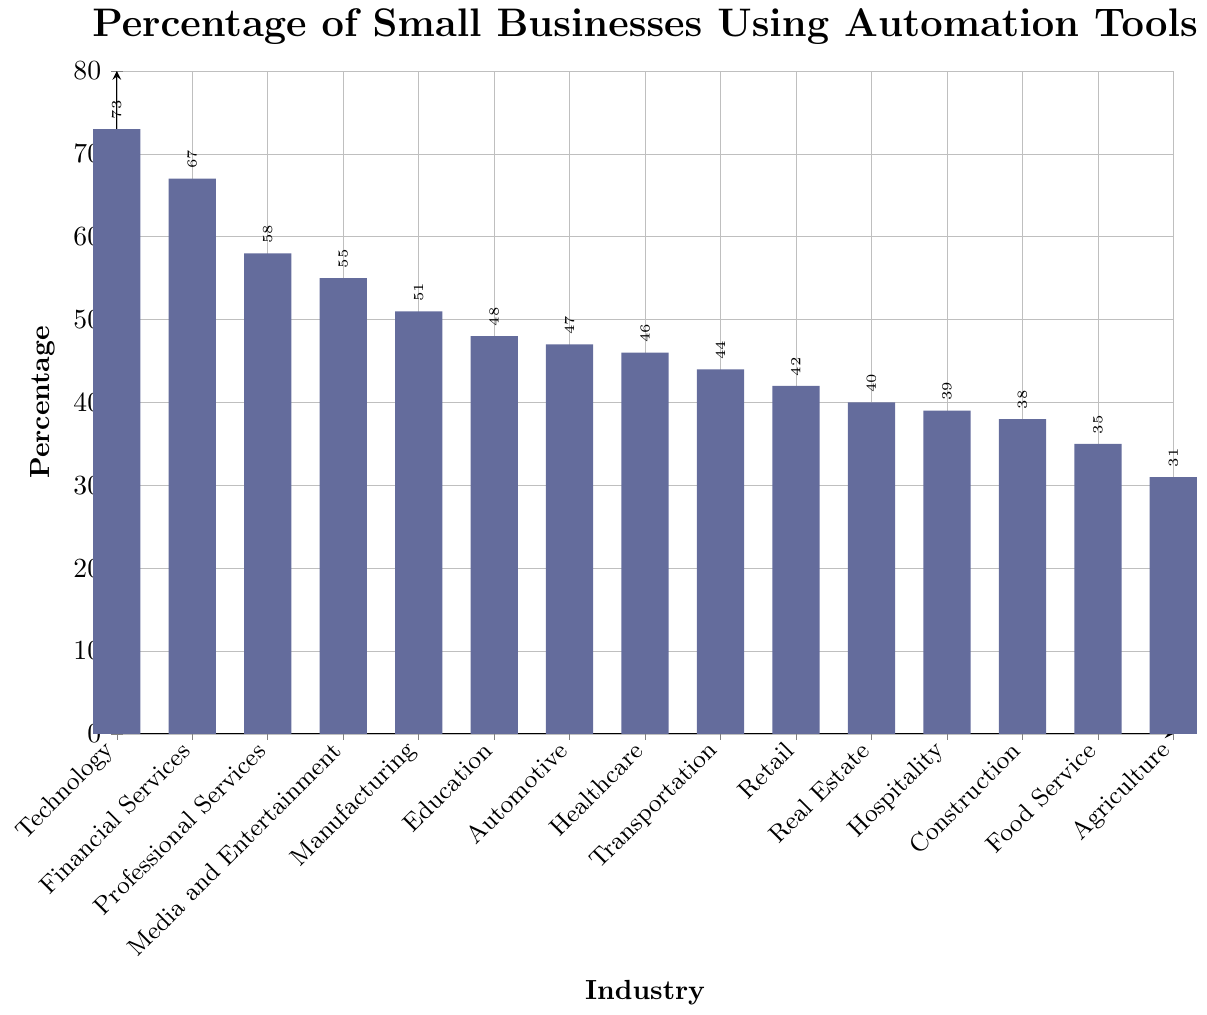what is the industry with the highest percentage of small businesses using automation tools By looking at the heights of the bars in the chart, the tallest bar corresponds to the Technology industry which has the highest percentage.
Answer: Technology which industry has a higher percentage of automation tool adoption: Manufacturing or Retail? By comparing the heights of the bars, Manufacturing (51%) has a higher percentage than Retail (42%).
Answer: Manufacturing what is the median percentage of small businesses using automation tools in the given industries? To find the median, list all percentages in ascending order: 31, 35, 38, 39, 40, 42, 44, 46, 47, 48, 51, 55, 58, 67, 73; The median is the 8th value in this ordered list, which is 46.
Answer: 46 how does the percentage of Professional Services compare to Financial Services? By comparing the heights of the bars, Financial Services (67%) has a higher percentage than Professional Services (58%).
Answer: Financial Services what is the total percentage of small businesses using automation tools in Education and Healthcare combined? Sum the percentages for Education (48%) and Healthcare (46%): 48 + 46 = 94
Answer: 94 which industry has more small businesses using automation tools: Transportation or Food Service? By comparing the heights of the bars, Transportation (44%) has a higher percentage than Food Service (35%).
Answer: Transportation what is the difference in percentage between Agriculture and Real Estate? Subtract the percentage of Agriculture (31%) from Real Estate (40%): 40 - 31 = 9
Answer: 9 which color represents the bars in the chart? By looking at the visual attributes of the bars, the bars are filled with a shade that is a mix of blue and red.
Answer: mix of blue and red which has a lower percentage of small businesses using automation tools: Hospitality or Construction? By comparing the heights of the bars, Construction (38%) has a lower percentage than Hospitality (39%).
Answer: Construction how many industries have a percentage of small businesses using automation tools greater than 50%? Count the bars that exceed the 50% mark: Technology (73%), Financial Services (67%), Professional Services (58%), and Media and Entertainment (55%), Manufacturing (51%); there are 5 industries.
Answer: 5 